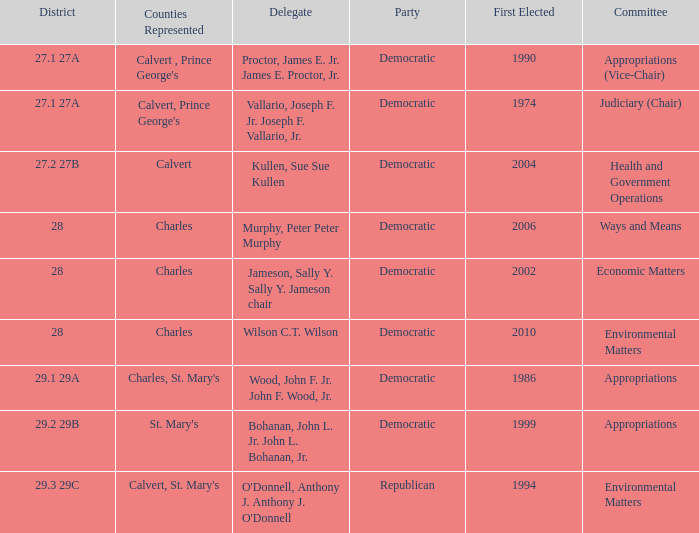Which was the district that had first elected greater than 2006 and is democratic? 28.0. 